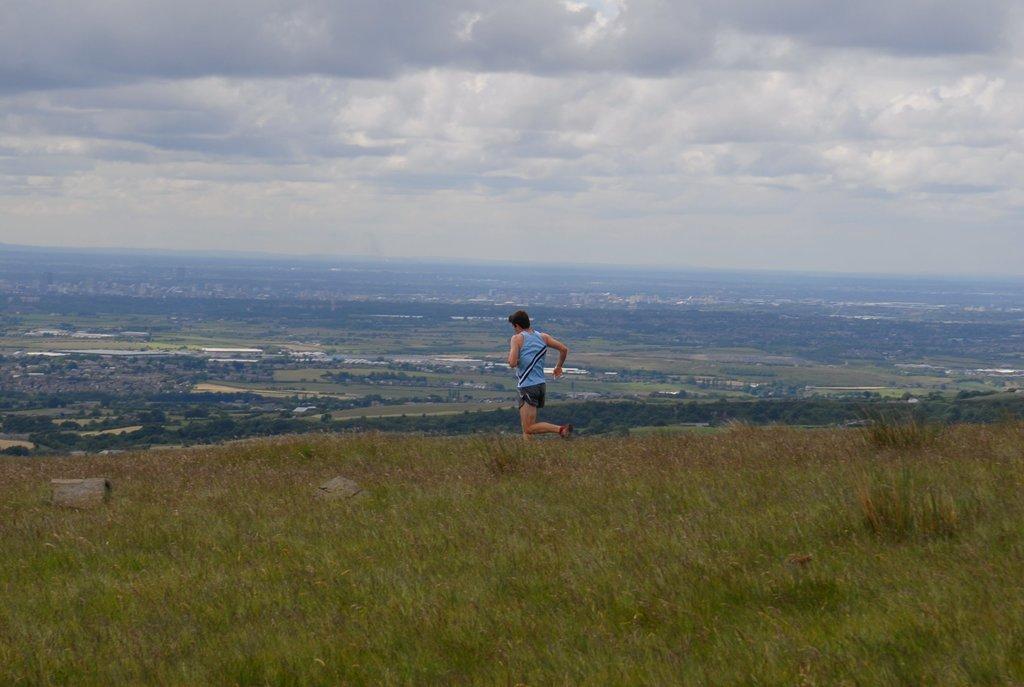Please provide a concise description of this image. In this picture we can see a man running on the ground, grass, trees and in the background we can see the sky with clouds. 